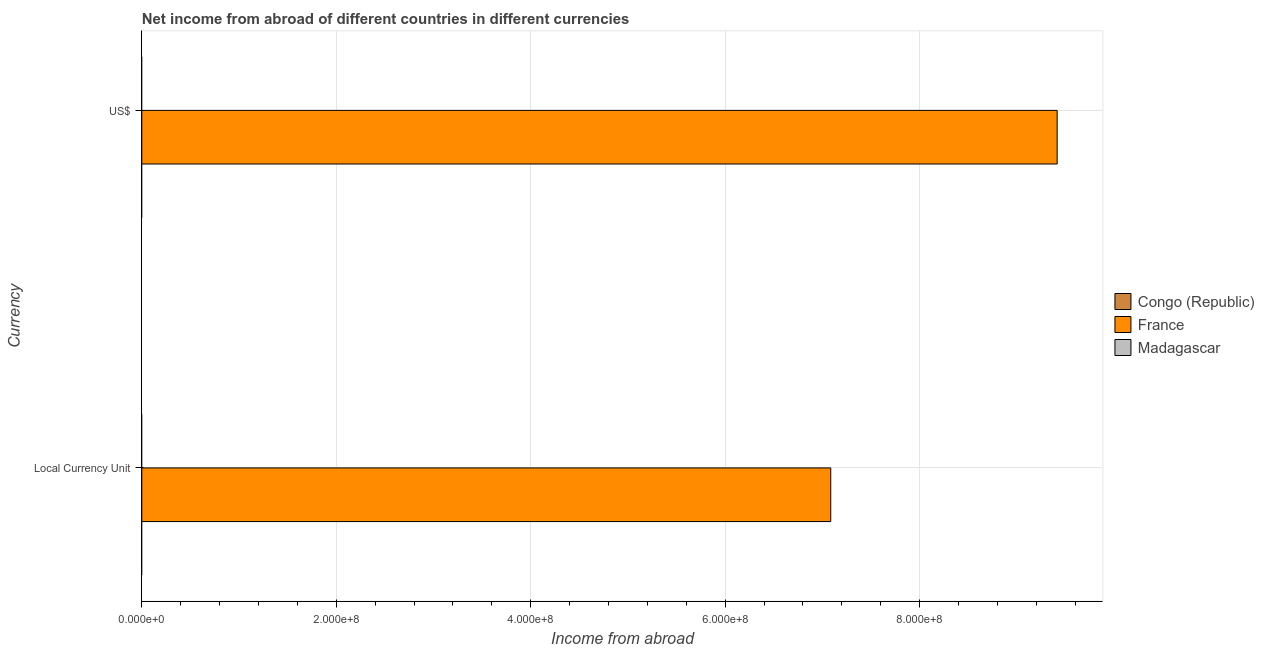Are the number of bars per tick equal to the number of legend labels?
Ensure brevity in your answer.  No. Are the number of bars on each tick of the Y-axis equal?
Your answer should be compact. Yes. How many bars are there on the 2nd tick from the top?
Keep it short and to the point. 1. What is the label of the 2nd group of bars from the top?
Make the answer very short. Local Currency Unit. What is the income from abroad in us$ in Madagascar?
Your answer should be very brief. 0. Across all countries, what is the maximum income from abroad in constant 2005 us$?
Offer a terse response. 7.09e+08. In which country was the income from abroad in constant 2005 us$ maximum?
Your answer should be compact. France. What is the total income from abroad in constant 2005 us$ in the graph?
Your answer should be compact. 7.09e+08. What is the average income from abroad in us$ per country?
Provide a short and direct response. 3.14e+08. What is the difference between the income from abroad in us$ and income from abroad in constant 2005 us$ in France?
Ensure brevity in your answer.  2.33e+08. In how many countries, is the income from abroad in constant 2005 us$ greater than 520000000 units?
Make the answer very short. 1. How many bars are there?
Offer a very short reply. 2. Are all the bars in the graph horizontal?
Offer a very short reply. Yes. How many countries are there in the graph?
Your response must be concise. 3. Are the values on the major ticks of X-axis written in scientific E-notation?
Offer a terse response. Yes. Does the graph contain grids?
Ensure brevity in your answer.  Yes. Where does the legend appear in the graph?
Your response must be concise. Center right. How many legend labels are there?
Your answer should be very brief. 3. How are the legend labels stacked?
Provide a succinct answer. Vertical. What is the title of the graph?
Your response must be concise. Net income from abroad of different countries in different currencies. Does "Congo (Democratic)" appear as one of the legend labels in the graph?
Provide a short and direct response. No. What is the label or title of the X-axis?
Your answer should be compact. Income from abroad. What is the label or title of the Y-axis?
Give a very brief answer. Currency. What is the Income from abroad in Congo (Republic) in Local Currency Unit?
Offer a very short reply. 0. What is the Income from abroad in France in Local Currency Unit?
Provide a succinct answer. 7.09e+08. What is the Income from abroad of Madagascar in Local Currency Unit?
Offer a terse response. 0. What is the Income from abroad of France in US$?
Offer a terse response. 9.41e+08. What is the Income from abroad in Madagascar in US$?
Offer a very short reply. 0. Across all Currency, what is the maximum Income from abroad in France?
Your answer should be very brief. 9.41e+08. Across all Currency, what is the minimum Income from abroad in France?
Offer a terse response. 7.09e+08. What is the total Income from abroad of Congo (Republic) in the graph?
Offer a very short reply. 0. What is the total Income from abroad in France in the graph?
Give a very brief answer. 1.65e+09. What is the total Income from abroad of Madagascar in the graph?
Ensure brevity in your answer.  0. What is the difference between the Income from abroad of France in Local Currency Unit and that in US$?
Offer a very short reply. -2.33e+08. What is the average Income from abroad of France per Currency?
Give a very brief answer. 8.25e+08. What is the ratio of the Income from abroad of France in Local Currency Unit to that in US$?
Make the answer very short. 0.75. What is the difference between the highest and the second highest Income from abroad in France?
Offer a very short reply. 2.33e+08. What is the difference between the highest and the lowest Income from abroad of France?
Keep it short and to the point. 2.33e+08. 